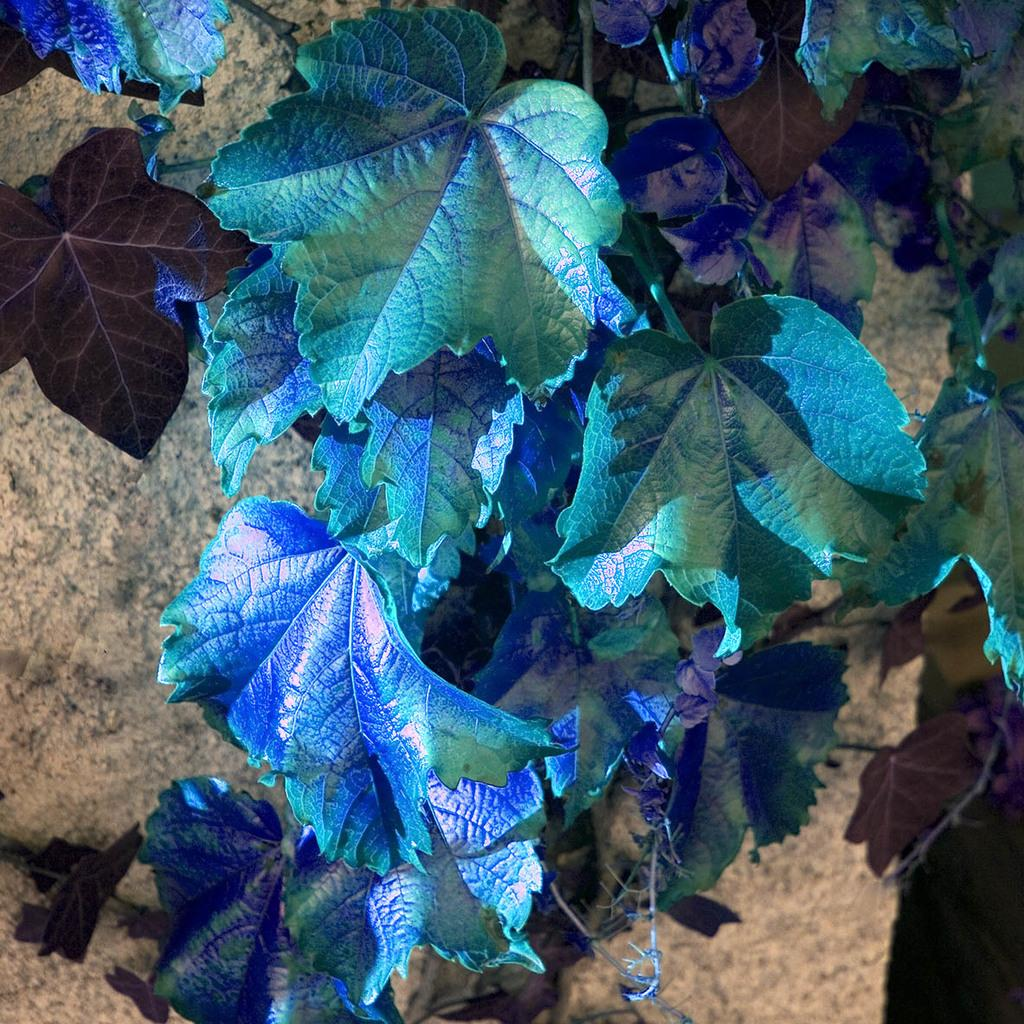What colors can be seen in the leaves in the image? The leaves in the image have blue and green colors. What part of the leaves connects them to the plant? The leaves have stems in the image. Where are the leaves located in the image? The leaves are on the ground in the image. What type of learning material can be seen in the image? There is no learning material present in the image; it features leaves on the ground. Can you see any lips on the leaves in the image? There are no lips present on the leaves in the image; they are simply leaves with stems and colors. 